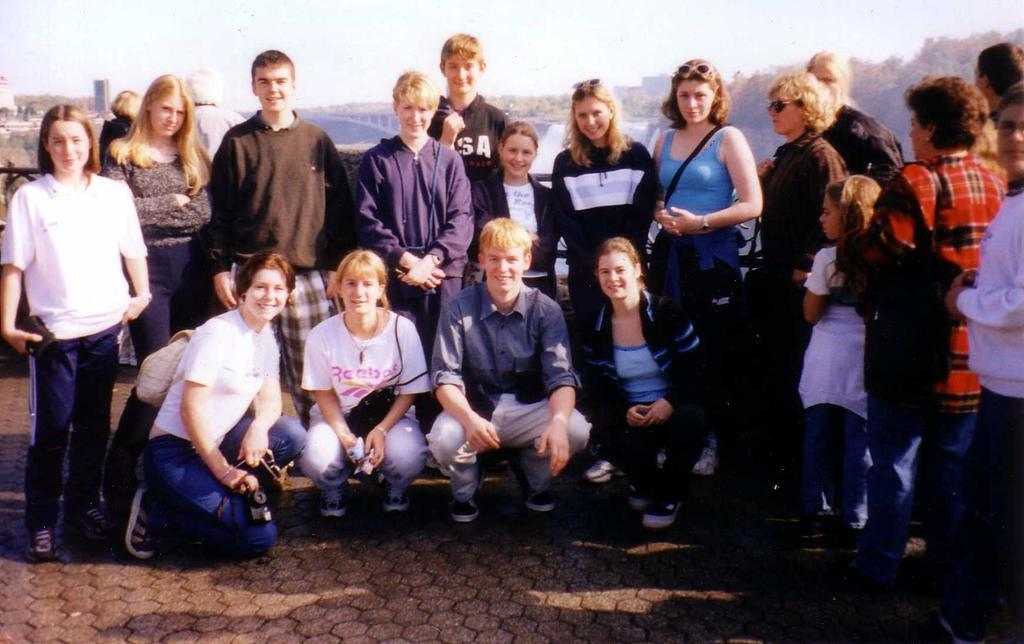How many people are in the image? There is a group of people standing in the image. What are four persons doing in the image? Four persons are in a squat position in the image. What can be seen in the background of the image? There are buildings, trees, a bridge, and the sky visible in the background of the image. How does the fan affect the rainstorm in the image? There is no fan or rainstorm present in the image. 